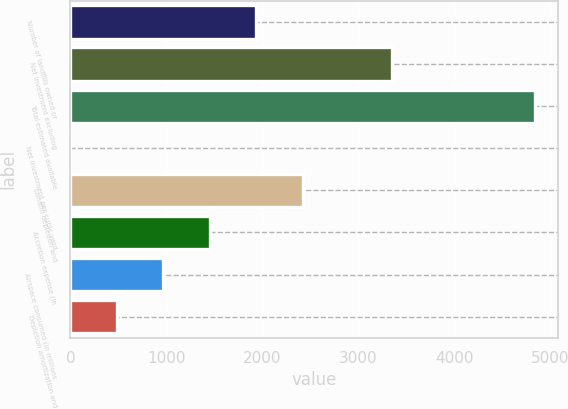<chart> <loc_0><loc_0><loc_500><loc_500><bar_chart><fcel>Number of landfills owned or<fcel>Net investment excluding<fcel>Total estimated available<fcel>Net investment per cubic yard<fcel>Landfill depletion and<fcel>Accretion expense (in<fcel>Airspace consumed (in millions<fcel>Depletion amortization and<nl><fcel>1938.73<fcel>3348.7<fcel>4845.8<fcel>0.69<fcel>2423.24<fcel>1454.22<fcel>969.71<fcel>485.2<nl></chart> 